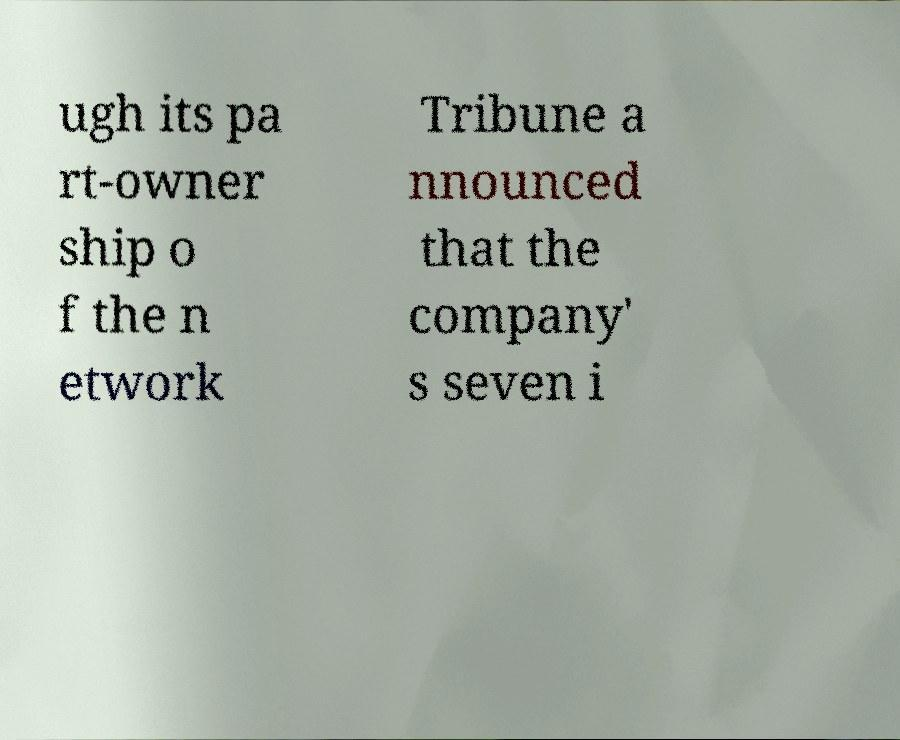Could you assist in decoding the text presented in this image and type it out clearly? ugh its pa rt-owner ship o f the n etwork Tribune a nnounced that the company' s seven i 